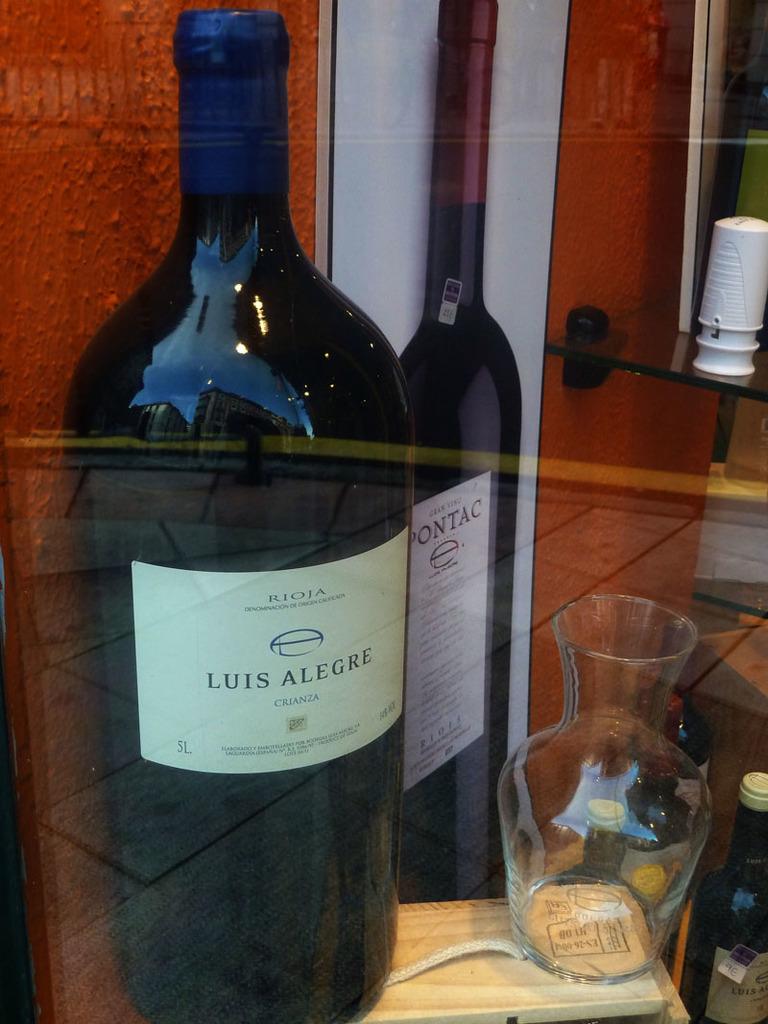How many liters are in the bottle?
Offer a terse response. 5. 